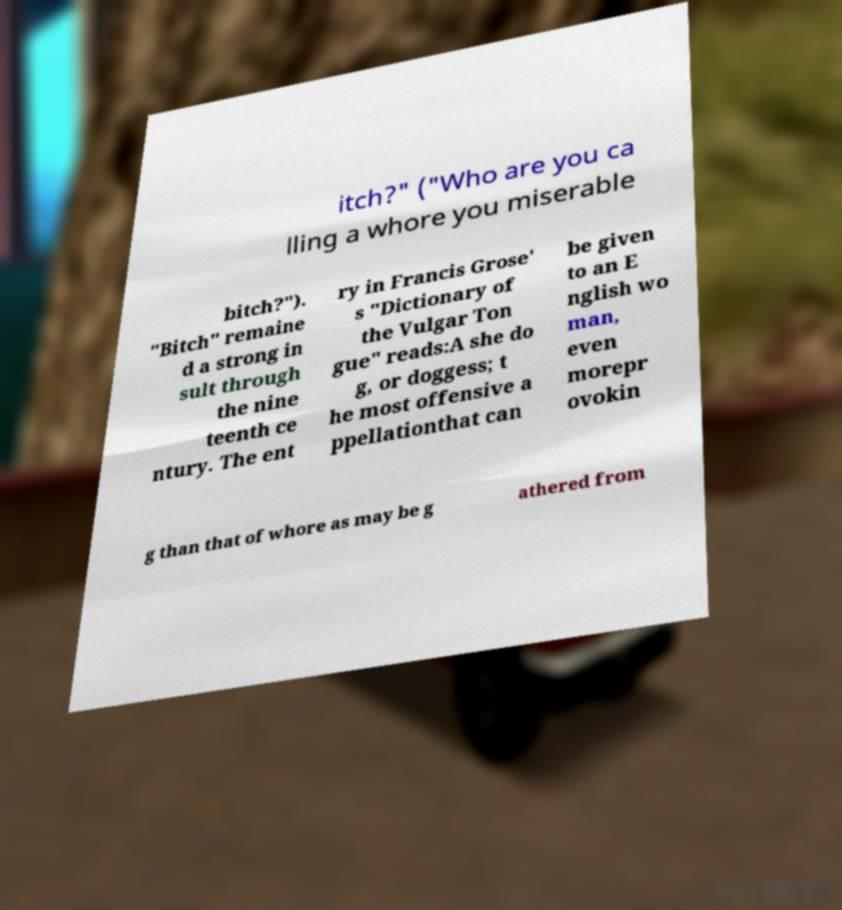Can you accurately transcribe the text from the provided image for me? itch?" ("Who are you ca lling a whore you miserable bitch?"). "Bitch" remaine d a strong in sult through the nine teenth ce ntury. The ent ry in Francis Grose' s "Dictionary of the Vulgar Ton gue" reads:A she do g, or doggess; t he most offensive a ppellationthat can be given to an E nglish wo man, even morepr ovokin g than that of whore as may be g athered from 